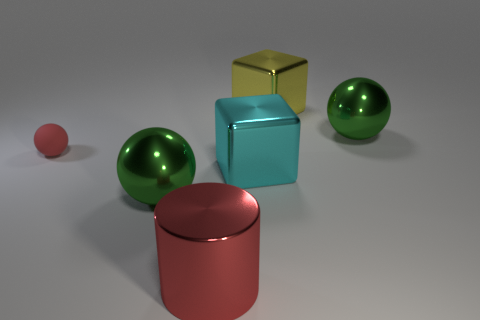Subtract all tiny red rubber spheres. How many spheres are left? 2 Subtract all blue cylinders. How many green spheres are left? 2 Add 1 big gray matte things. How many objects exist? 7 Subtract 1 spheres. How many spheres are left? 2 Subtract all blocks. How many objects are left? 4 Add 5 large yellow blocks. How many large yellow blocks exist? 6 Subtract 1 red balls. How many objects are left? 5 Subtract all purple cubes. Subtract all yellow balls. How many cubes are left? 2 Subtract all big cubes. Subtract all large cyan metallic blocks. How many objects are left? 3 Add 4 yellow cubes. How many yellow cubes are left? 5 